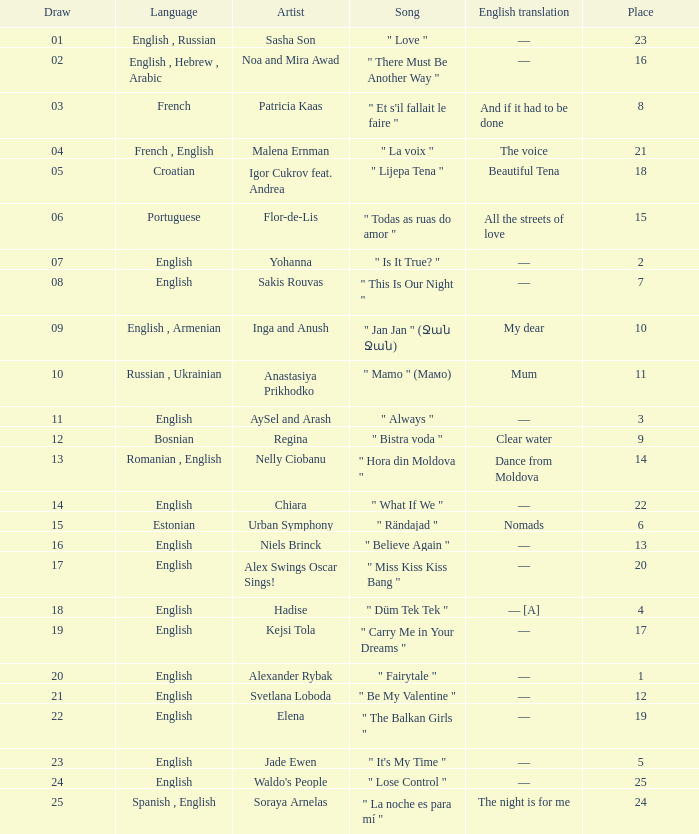What melody was in french? " Et s'il fallait le faire ". 